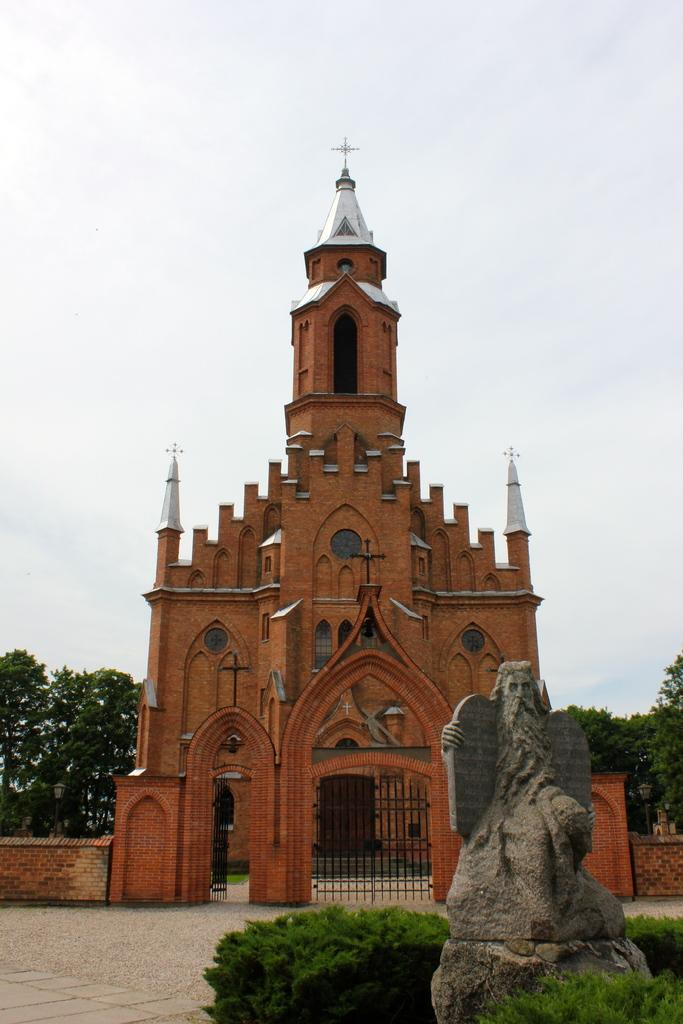What is the main structure in the middle of the image? There is a building in the middle of the image. What can be seen at the bottom of the image? There are plants and a statue at the bottom of the image. What is the surface on which the plants and statue are placed? There is a floor at the bottom of the image. What is visible in the background of the image? There are trees, sky, and clouds in the background of the image. How many plants are whistling in the image? There are no plants whistling in the image; plants do not have the ability to whistle. 